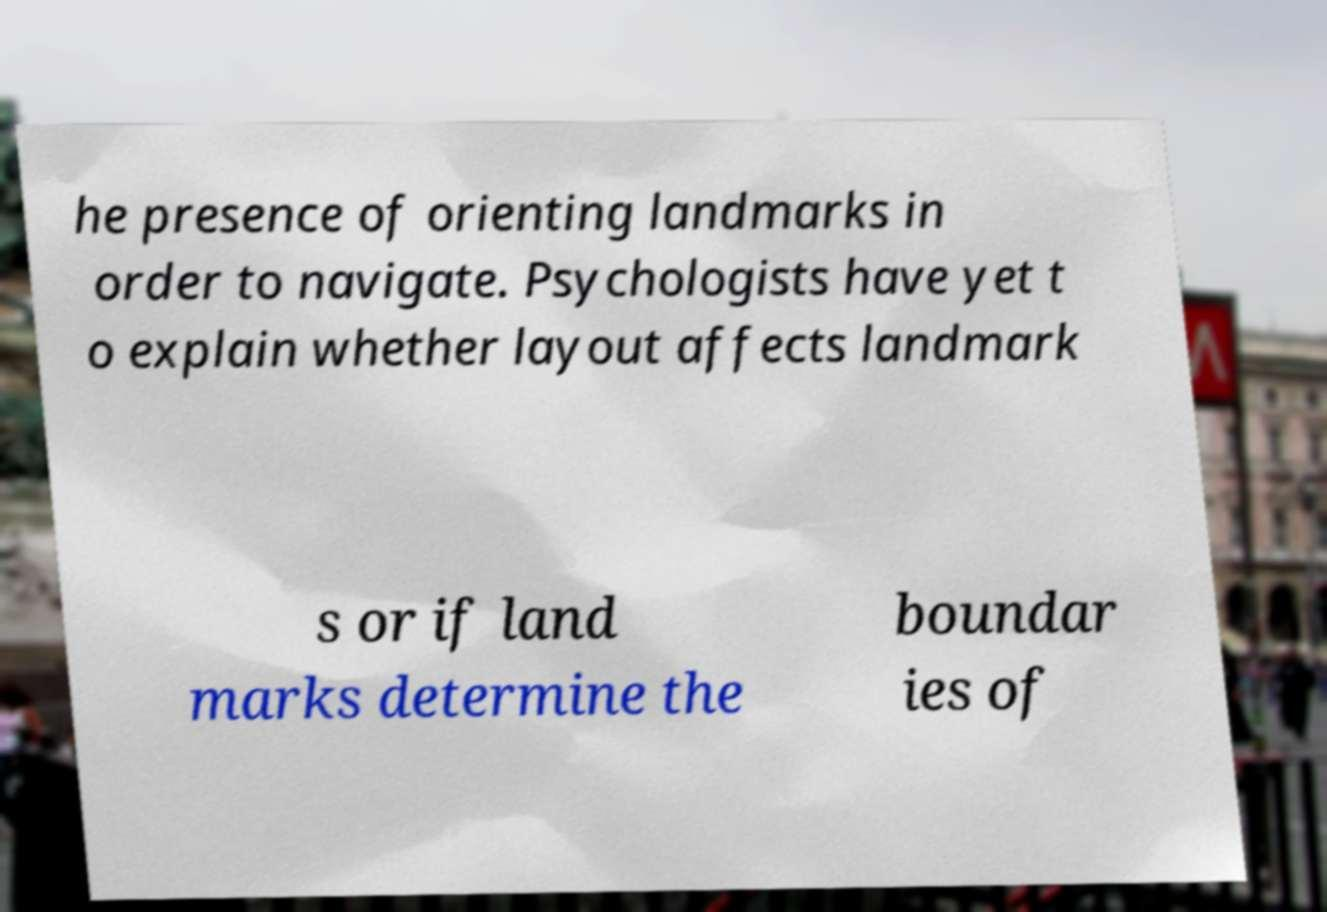There's text embedded in this image that I need extracted. Can you transcribe it verbatim? he presence of orienting landmarks in order to navigate. Psychologists have yet t o explain whether layout affects landmark s or if land marks determine the boundar ies of 